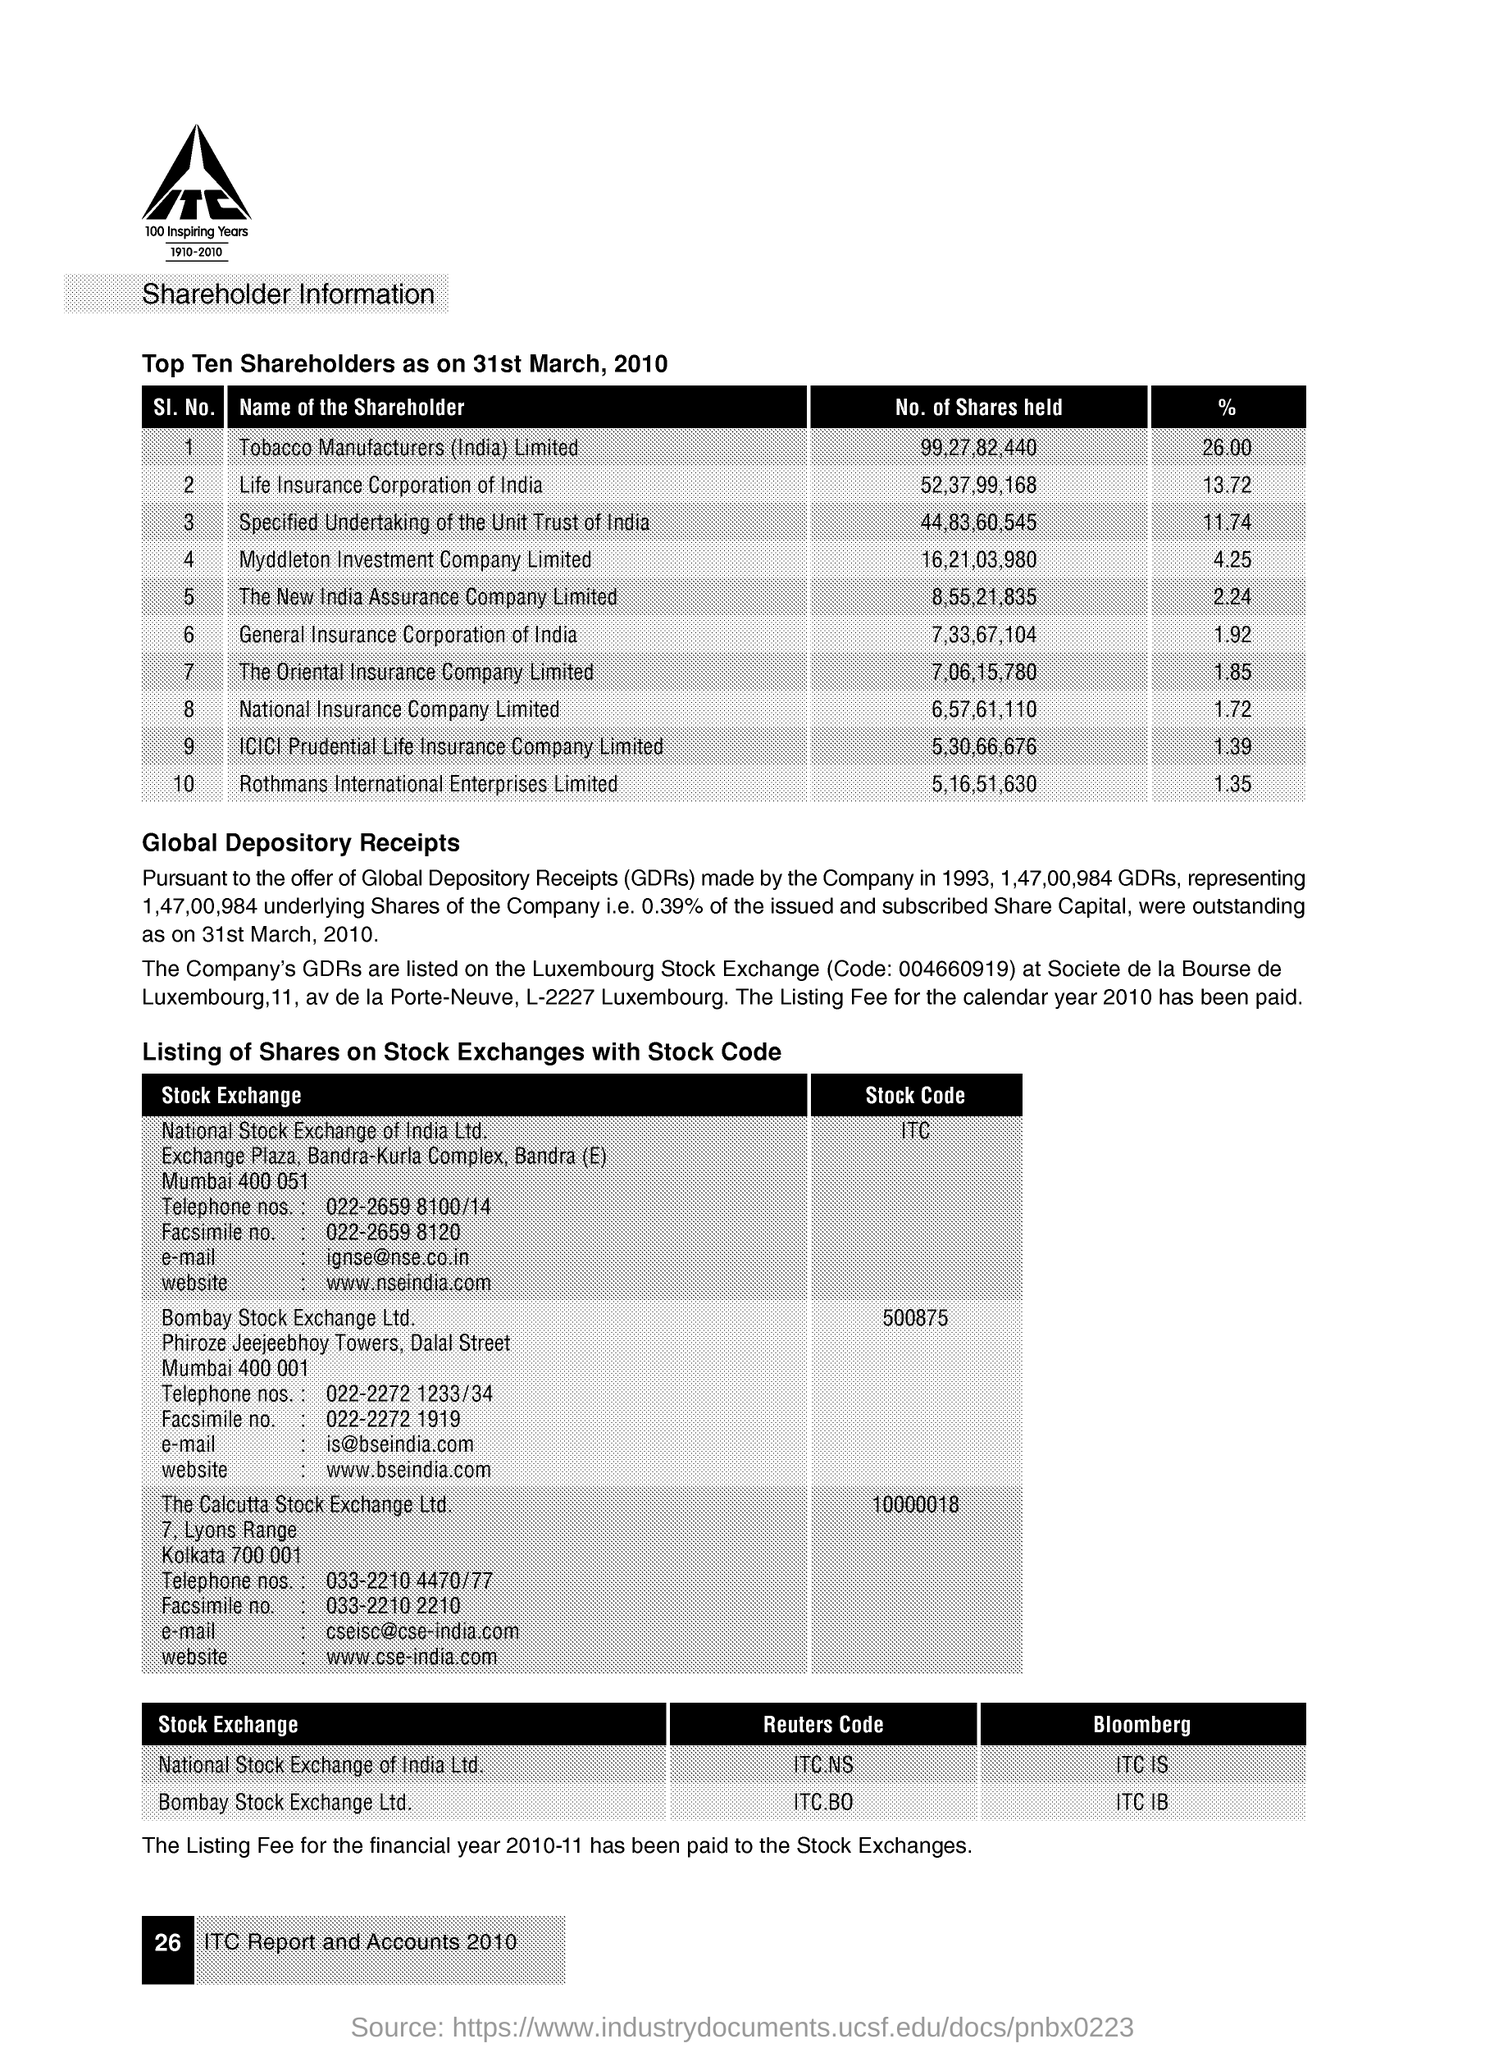Draw attention to some important aspects in this diagram. The unit trust of India holds 11.74% of shares in the specified undertaking. The percentage of shares held in New India Assurance Company Limited is 2.24%. There are 99,27,82,440 shareholders of Tobacco Manufacturers (India) Limited. The Life Insurance Corporation of India holds a number of shares that is approximately 52,37,99,168. There are 7,33,67,104 shareholders held in the General Insurance Corporation of India. 